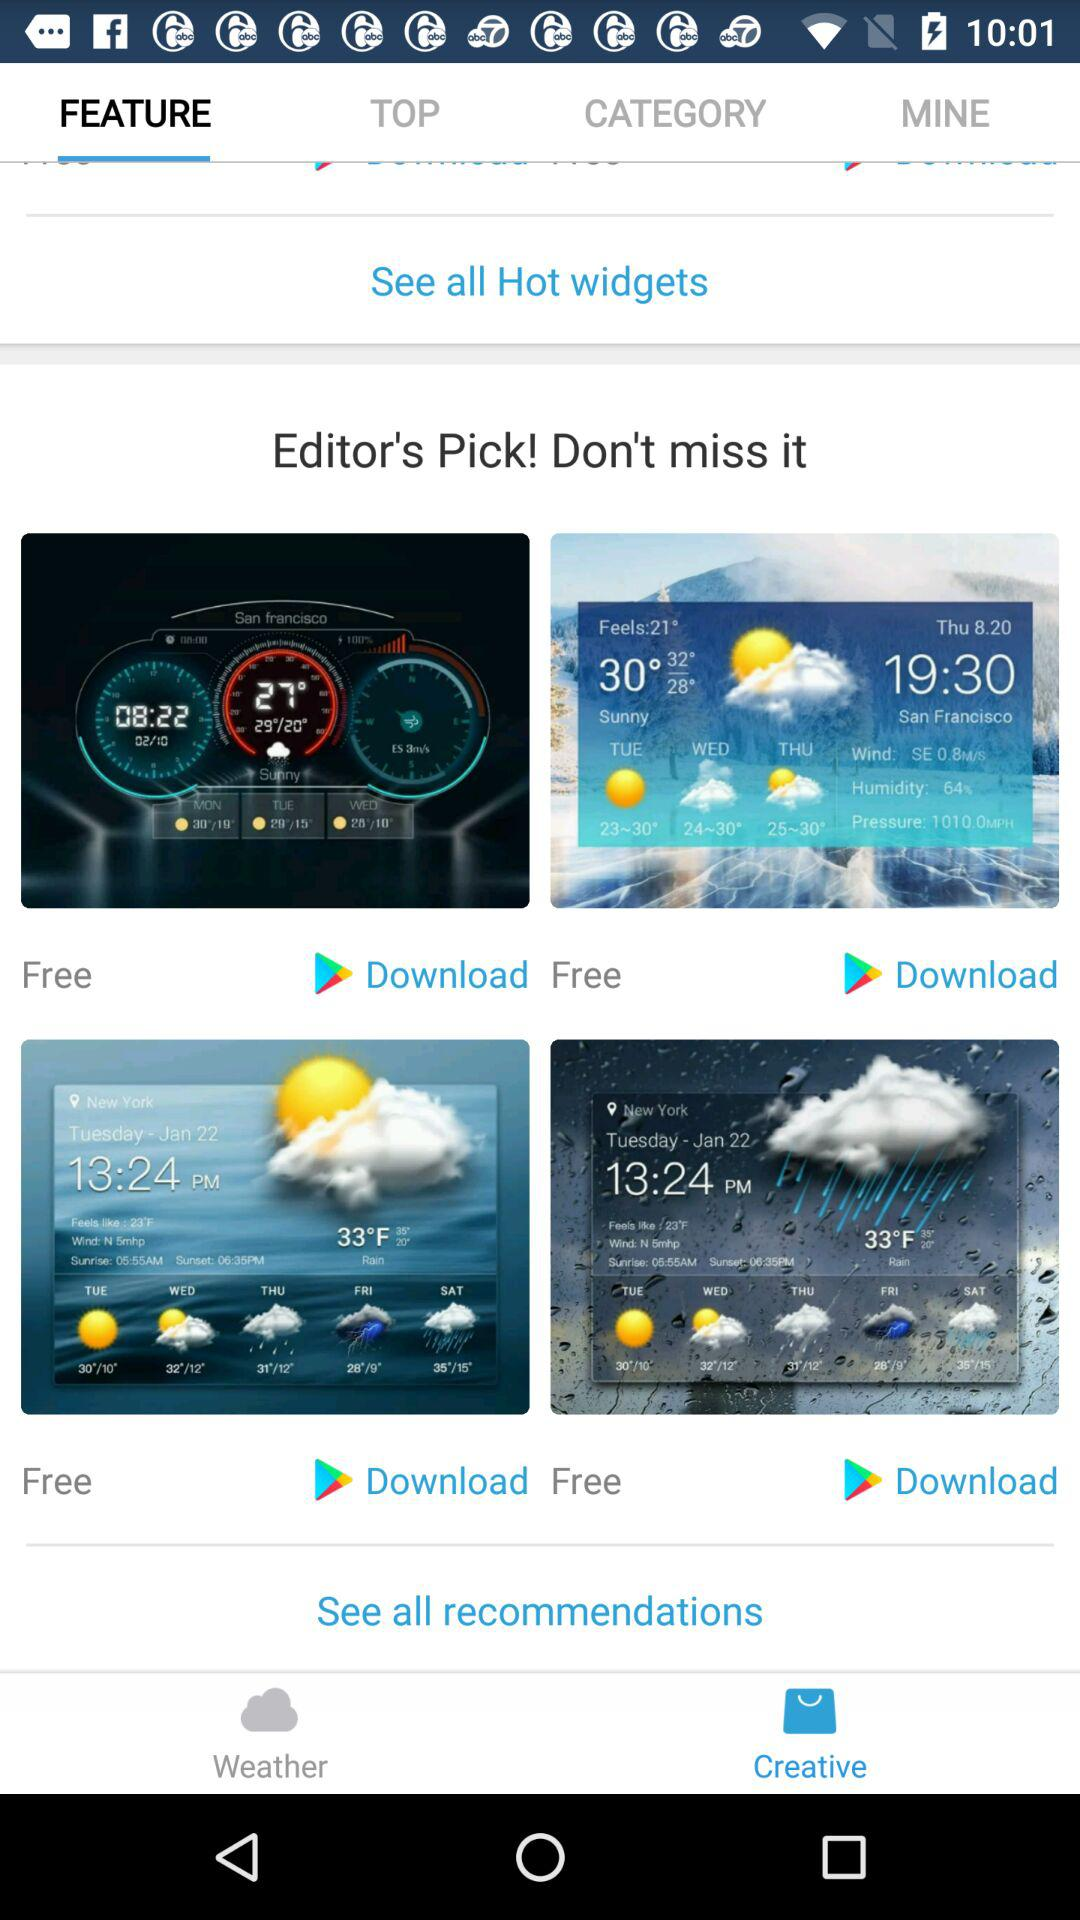How many widgets are free in total?
Answer the question using a single word or phrase. 4 